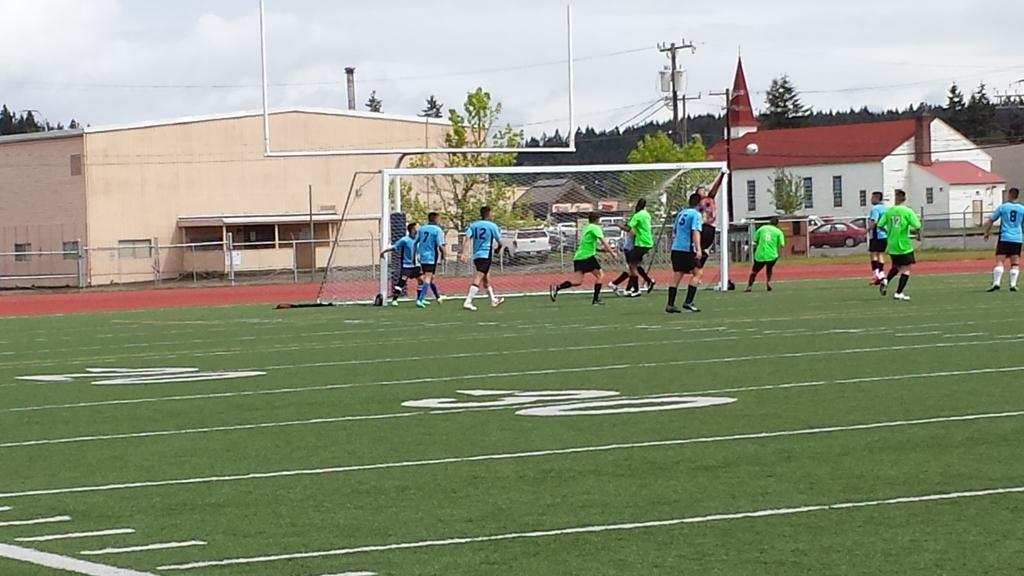What is the main subject of the image? The main subject of the image is a group of football players. What are the football players doing in the image? The football players are moving around the ground. What can be seen in the background of the image? There are houses and trees visible behind the ground. How many cats are playing with a bucket in the image? There are no cats or buckets present in the image. What type of wing is visible on one of the football players in the image? There are no wings visible on any of the football players in the image. 